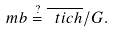<formula> <loc_0><loc_0><loc_500><loc_500>\ m b \stackrel { ? } { = } \overline { \ t i c h } / G .</formula> 